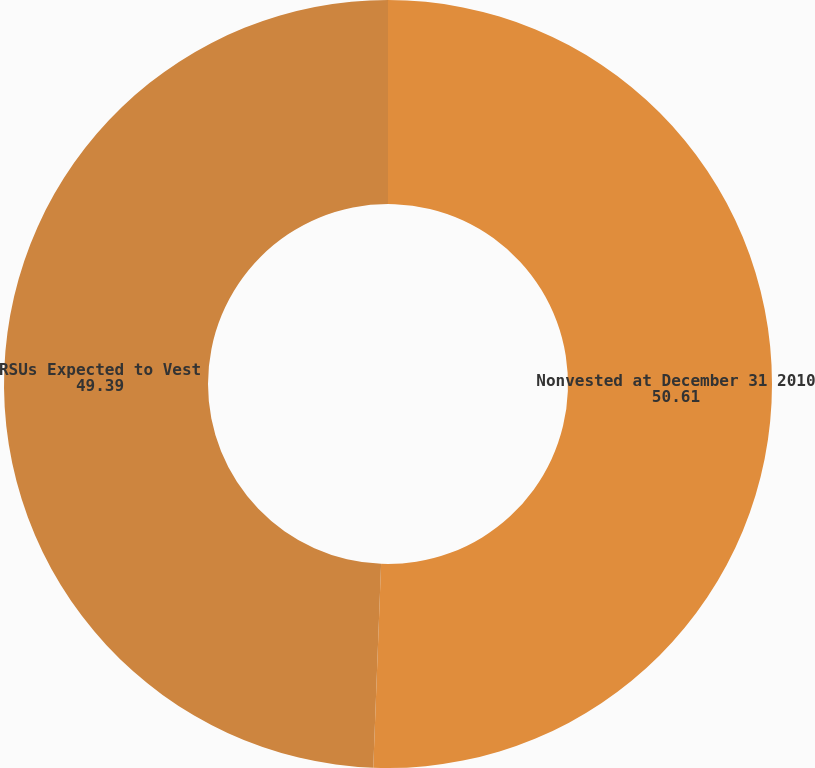<chart> <loc_0><loc_0><loc_500><loc_500><pie_chart><fcel>Nonvested at December 31 2010<fcel>RSUs Expected to Vest<nl><fcel>50.61%<fcel>49.39%<nl></chart> 